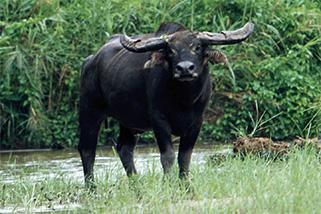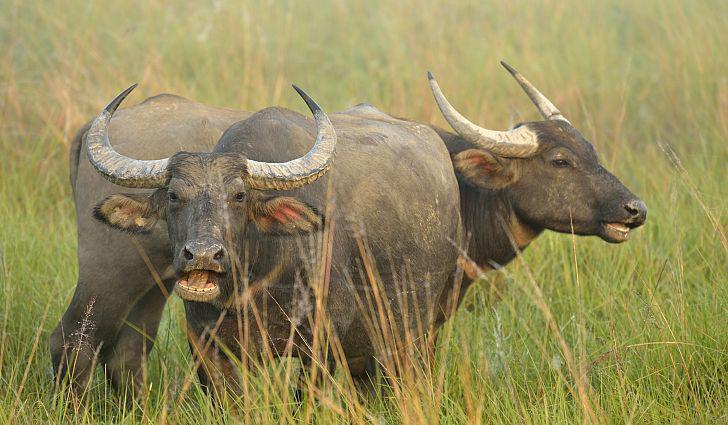The first image is the image on the left, the second image is the image on the right. Analyze the images presented: Is the assertion "One of the images contains an animal that is not a water buffalo." valid? Answer yes or no. No. The first image is the image on the left, the second image is the image on the right. Given the left and right images, does the statement "There are at least five water buffalo." hold true? Answer yes or no. No. 